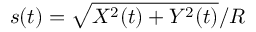<formula> <loc_0><loc_0><loc_500><loc_500>s ( t ) = \sqrt { X ^ { 2 } ( t ) + Y ^ { 2 } ( t ) } / R</formula> 